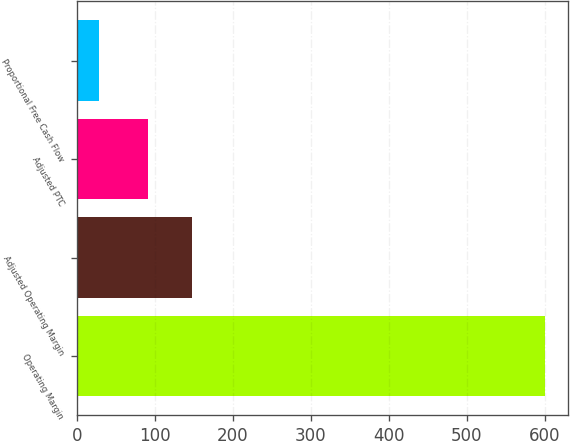<chart> <loc_0><loc_0><loc_500><loc_500><bar_chart><fcel>Operating Margin<fcel>Adjusted Operating Margin<fcel>Adjusted PTC<fcel>Proportional Free Cash Flow<nl><fcel>600<fcel>148.1<fcel>91<fcel>29<nl></chart> 